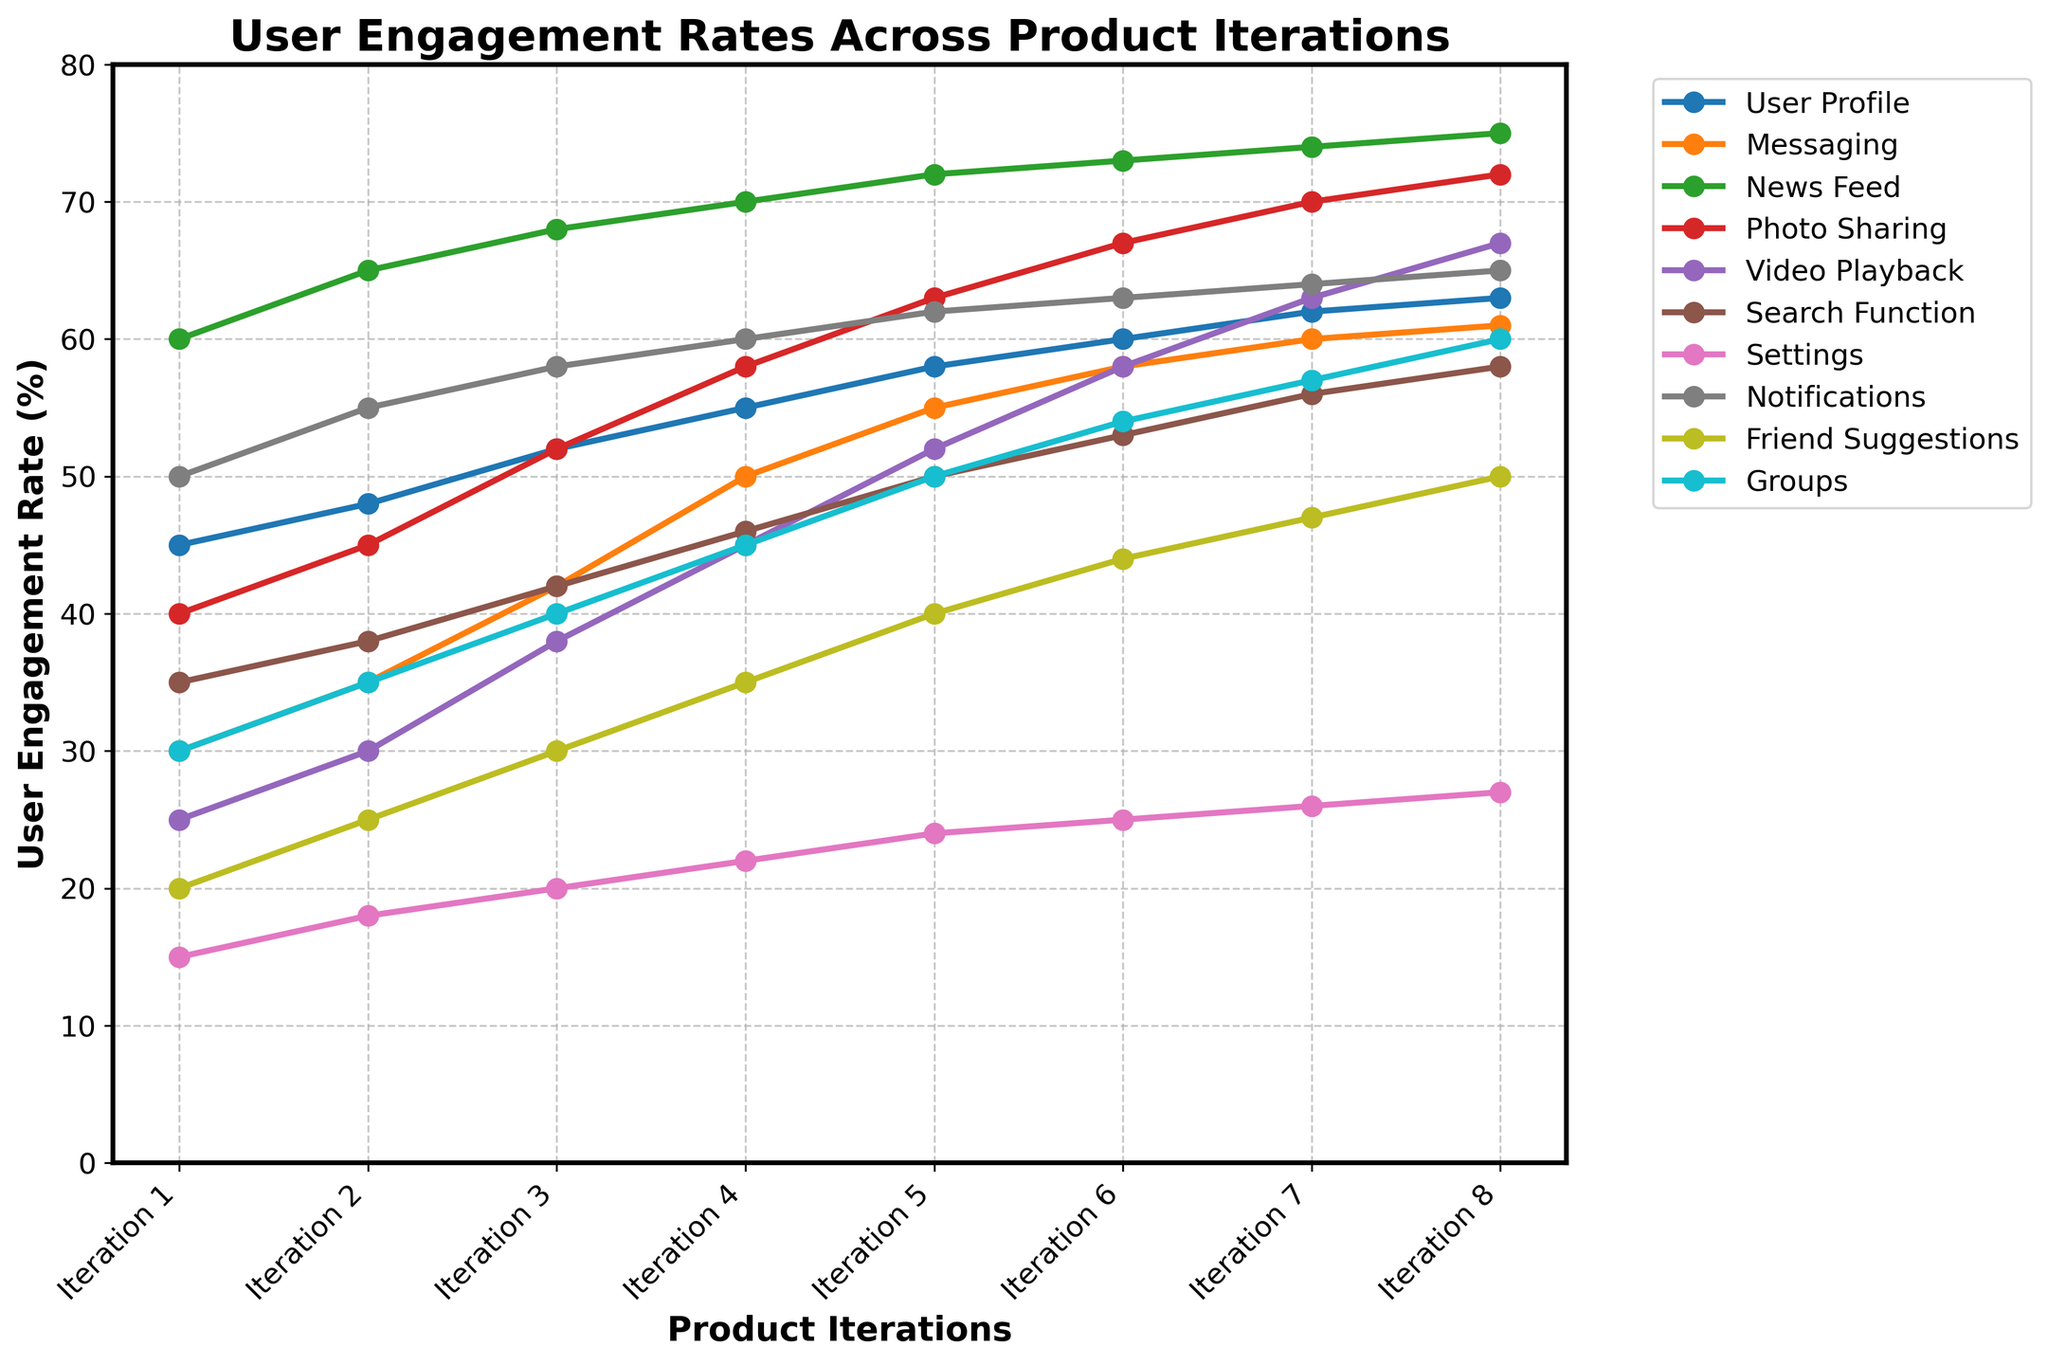What is the feature with the lowest user engagement rate in Iteration 3? In Iteration 3, we need to compare the engagement rates of all features. The feature with the lowest rate is Settings with a rate of 20%.
Answer: Settings Which feature shows the highest user engagement rate growth from Iteration 1 to Iteration 8? Calculate the growth for each feature by subtracting the engagement rate in Iteration 1 from Iteration 8. The feature with the highest growth is Video Playback with a growth of 42% (67% - 25%).
Answer: Video Playback What is the average user engagement rate for Photo Sharing over all iterations? Sum the engagement rates for Photo Sharing across all iterations (40 + 45 + 52 + 58 + 63 + 67 + 70 + 72) = 467 and divide by the number of iterations (8). The average rate is 467 / 8 = 58.375%.
Answer: 58.375% Which two features have equal user engagement rates in Iteration 6? Compare the engagement rates of all features in Iteration 6. The features Messaging and Video Playback both have an engagement rate of 58%.
Answer: Messaging and Video Playback How does the user engagement rate of Notifications evolve from Iteration 1 to Iteration 8? Track the engagement rates of Notifications across all iterations: 50%, 55%, 58%, 60%, 62%, 63%, 64%, and 65%. The rate consistently increases over the iterations.
Answer: Consistently increases What is the difference in the user engagement rate between User Profile and Search Function in Iteration 4? Subtract the engagement rate of Search Function (46%) from that of User Profile (55%) in Iteration 4. The difference is 55% - 46% = 9%.
Answer: 9% Does any feature show a decrease in user engagement rate between two consecutive iterations? Check each feature's engagement rates across consecutive iterations. No feature shows a decrease; all rates either increase or remain the same.
Answer: No Which feature has the most consistent increase in user engagement rates across all iterations? Analyze the engagement rates of all features across the iterations. The News Feed shows a steady increase without any plateau, growing from 60% to 75%.
Answer: News Feed What is the median user engagement rate for Groups in all iterations? List the engagement rates for Groups across all iterations (30, 35, 40, 45, 50, 54, 57, 60) and find the median value. Since there are 8 values, the median is the average of the 4th and 5th values (45 + 50) / 2 = 47.5.
Answer: 47.5 